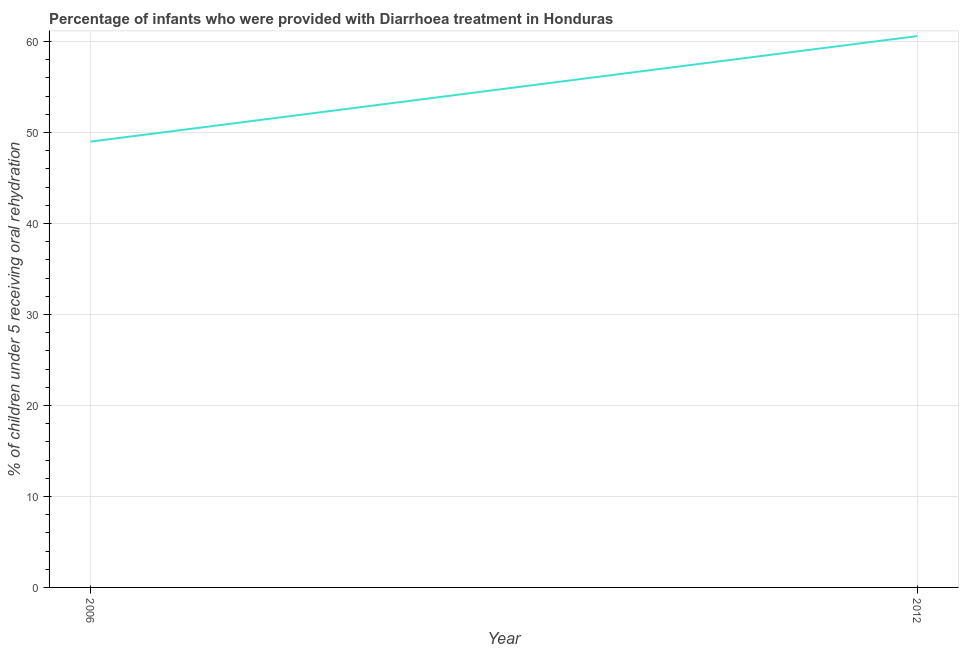What is the percentage of children who were provided with treatment diarrhoea in 2012?
Offer a very short reply. 60.6. Across all years, what is the maximum percentage of children who were provided with treatment diarrhoea?
Your answer should be very brief. 60.6. In which year was the percentage of children who were provided with treatment diarrhoea maximum?
Keep it short and to the point. 2012. What is the sum of the percentage of children who were provided with treatment diarrhoea?
Your response must be concise. 109.6. What is the difference between the percentage of children who were provided with treatment diarrhoea in 2006 and 2012?
Ensure brevity in your answer.  -11.6. What is the average percentage of children who were provided with treatment diarrhoea per year?
Keep it short and to the point. 54.8. What is the median percentage of children who were provided with treatment diarrhoea?
Your answer should be compact. 54.8. In how many years, is the percentage of children who were provided with treatment diarrhoea greater than 16 %?
Your response must be concise. 2. Do a majority of the years between 2006 and 2012 (inclusive) have percentage of children who were provided with treatment diarrhoea greater than 2 %?
Ensure brevity in your answer.  Yes. What is the ratio of the percentage of children who were provided with treatment diarrhoea in 2006 to that in 2012?
Offer a terse response. 0.81. How many years are there in the graph?
Your response must be concise. 2. What is the difference between two consecutive major ticks on the Y-axis?
Offer a terse response. 10. Does the graph contain any zero values?
Provide a short and direct response. No. What is the title of the graph?
Offer a very short reply. Percentage of infants who were provided with Diarrhoea treatment in Honduras. What is the label or title of the X-axis?
Your response must be concise. Year. What is the label or title of the Y-axis?
Ensure brevity in your answer.  % of children under 5 receiving oral rehydration. What is the % of children under 5 receiving oral rehydration of 2012?
Your response must be concise. 60.6. What is the ratio of the % of children under 5 receiving oral rehydration in 2006 to that in 2012?
Ensure brevity in your answer.  0.81. 